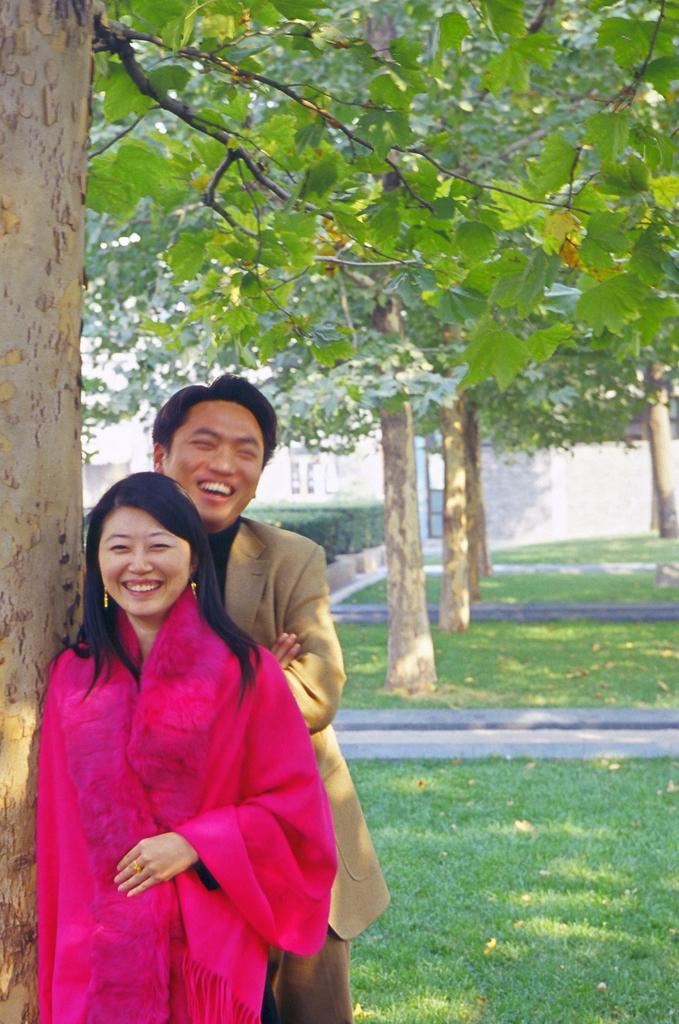How would you summarize this image in a sentence or two? In this picture there are two persons standing and smiling. At the back there are trees and there is a building. At the bottom there is grass and there are plants. 